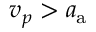Convert formula to latex. <formula><loc_0><loc_0><loc_500><loc_500>v _ { p } > a _ { a }</formula> 